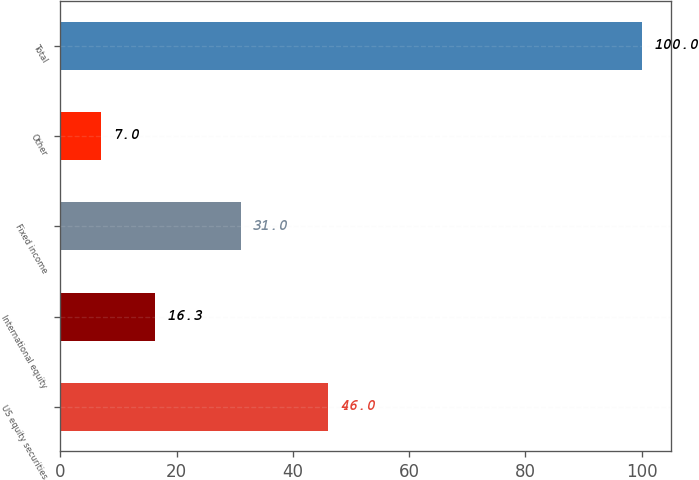<chart> <loc_0><loc_0><loc_500><loc_500><bar_chart><fcel>US equity securities<fcel>International equity<fcel>Fixed income<fcel>Other<fcel>Total<nl><fcel>46<fcel>16.3<fcel>31<fcel>7<fcel>100<nl></chart> 